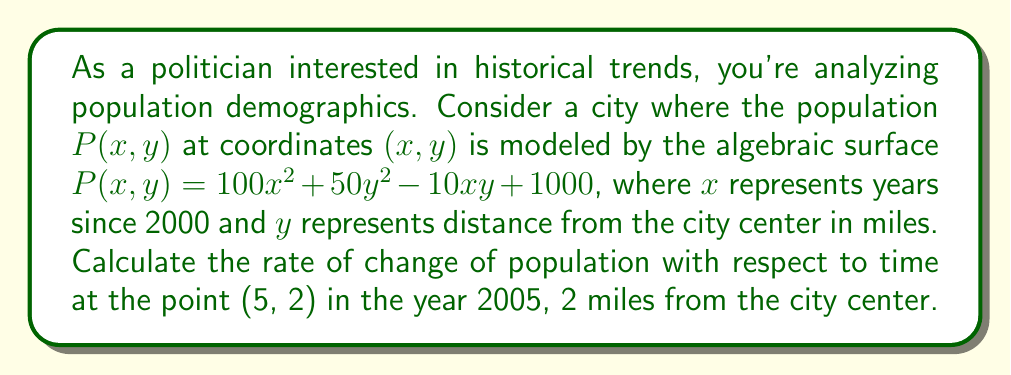Can you answer this question? To solve this problem, we need to find the partial derivative of $P(x,y)$ with respect to $x$, which represents time, and then evaluate it at the point (5, 2).

Step 1: Find the partial derivative of $P(x,y)$ with respect to $x$.
$$\frac{\partial P}{\partial x} = 200x - 10y$$

Step 2: Evaluate the partial derivative at the point (5, 2).
$$\frac{\partial P}{\partial x}\bigg|_{(5,2)} = 200(5) - 10(2)$$
$$= 1000 - 20$$
$$= 980$$

Step 3: Interpret the result.
The rate of change of population with respect to time at the point (5, 2) is 980 people per year. This means that in the year 2005, at a location 2 miles from the city center, the population is increasing at a rate of 980 people per year.
Answer: 980 people/year 